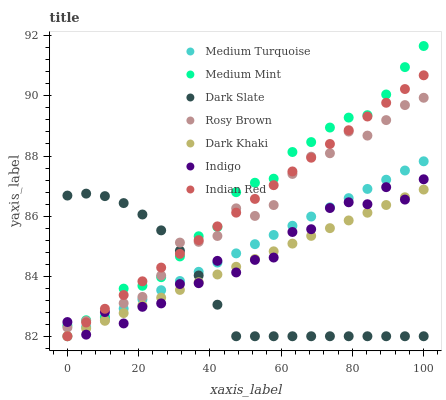Does Dark Slate have the minimum area under the curve?
Answer yes or no. Yes. Does Medium Mint have the maximum area under the curve?
Answer yes or no. Yes. Does Indigo have the minimum area under the curve?
Answer yes or no. No. Does Indigo have the maximum area under the curve?
Answer yes or no. No. Is Dark Khaki the smoothest?
Answer yes or no. Yes. Is Indigo the roughest?
Answer yes or no. Yes. Is Indian Red the smoothest?
Answer yes or no. No. Is Indian Red the roughest?
Answer yes or no. No. Does Indian Red have the lowest value?
Answer yes or no. Yes. Does Indigo have the lowest value?
Answer yes or no. No. Does Medium Mint have the highest value?
Answer yes or no. Yes. Does Indigo have the highest value?
Answer yes or no. No. Is Medium Turquoise less than Medium Mint?
Answer yes or no. Yes. Is Medium Mint greater than Dark Khaki?
Answer yes or no. Yes. Does Dark Slate intersect Dark Khaki?
Answer yes or no. Yes. Is Dark Slate less than Dark Khaki?
Answer yes or no. No. Is Dark Slate greater than Dark Khaki?
Answer yes or no. No. Does Medium Turquoise intersect Medium Mint?
Answer yes or no. No. 